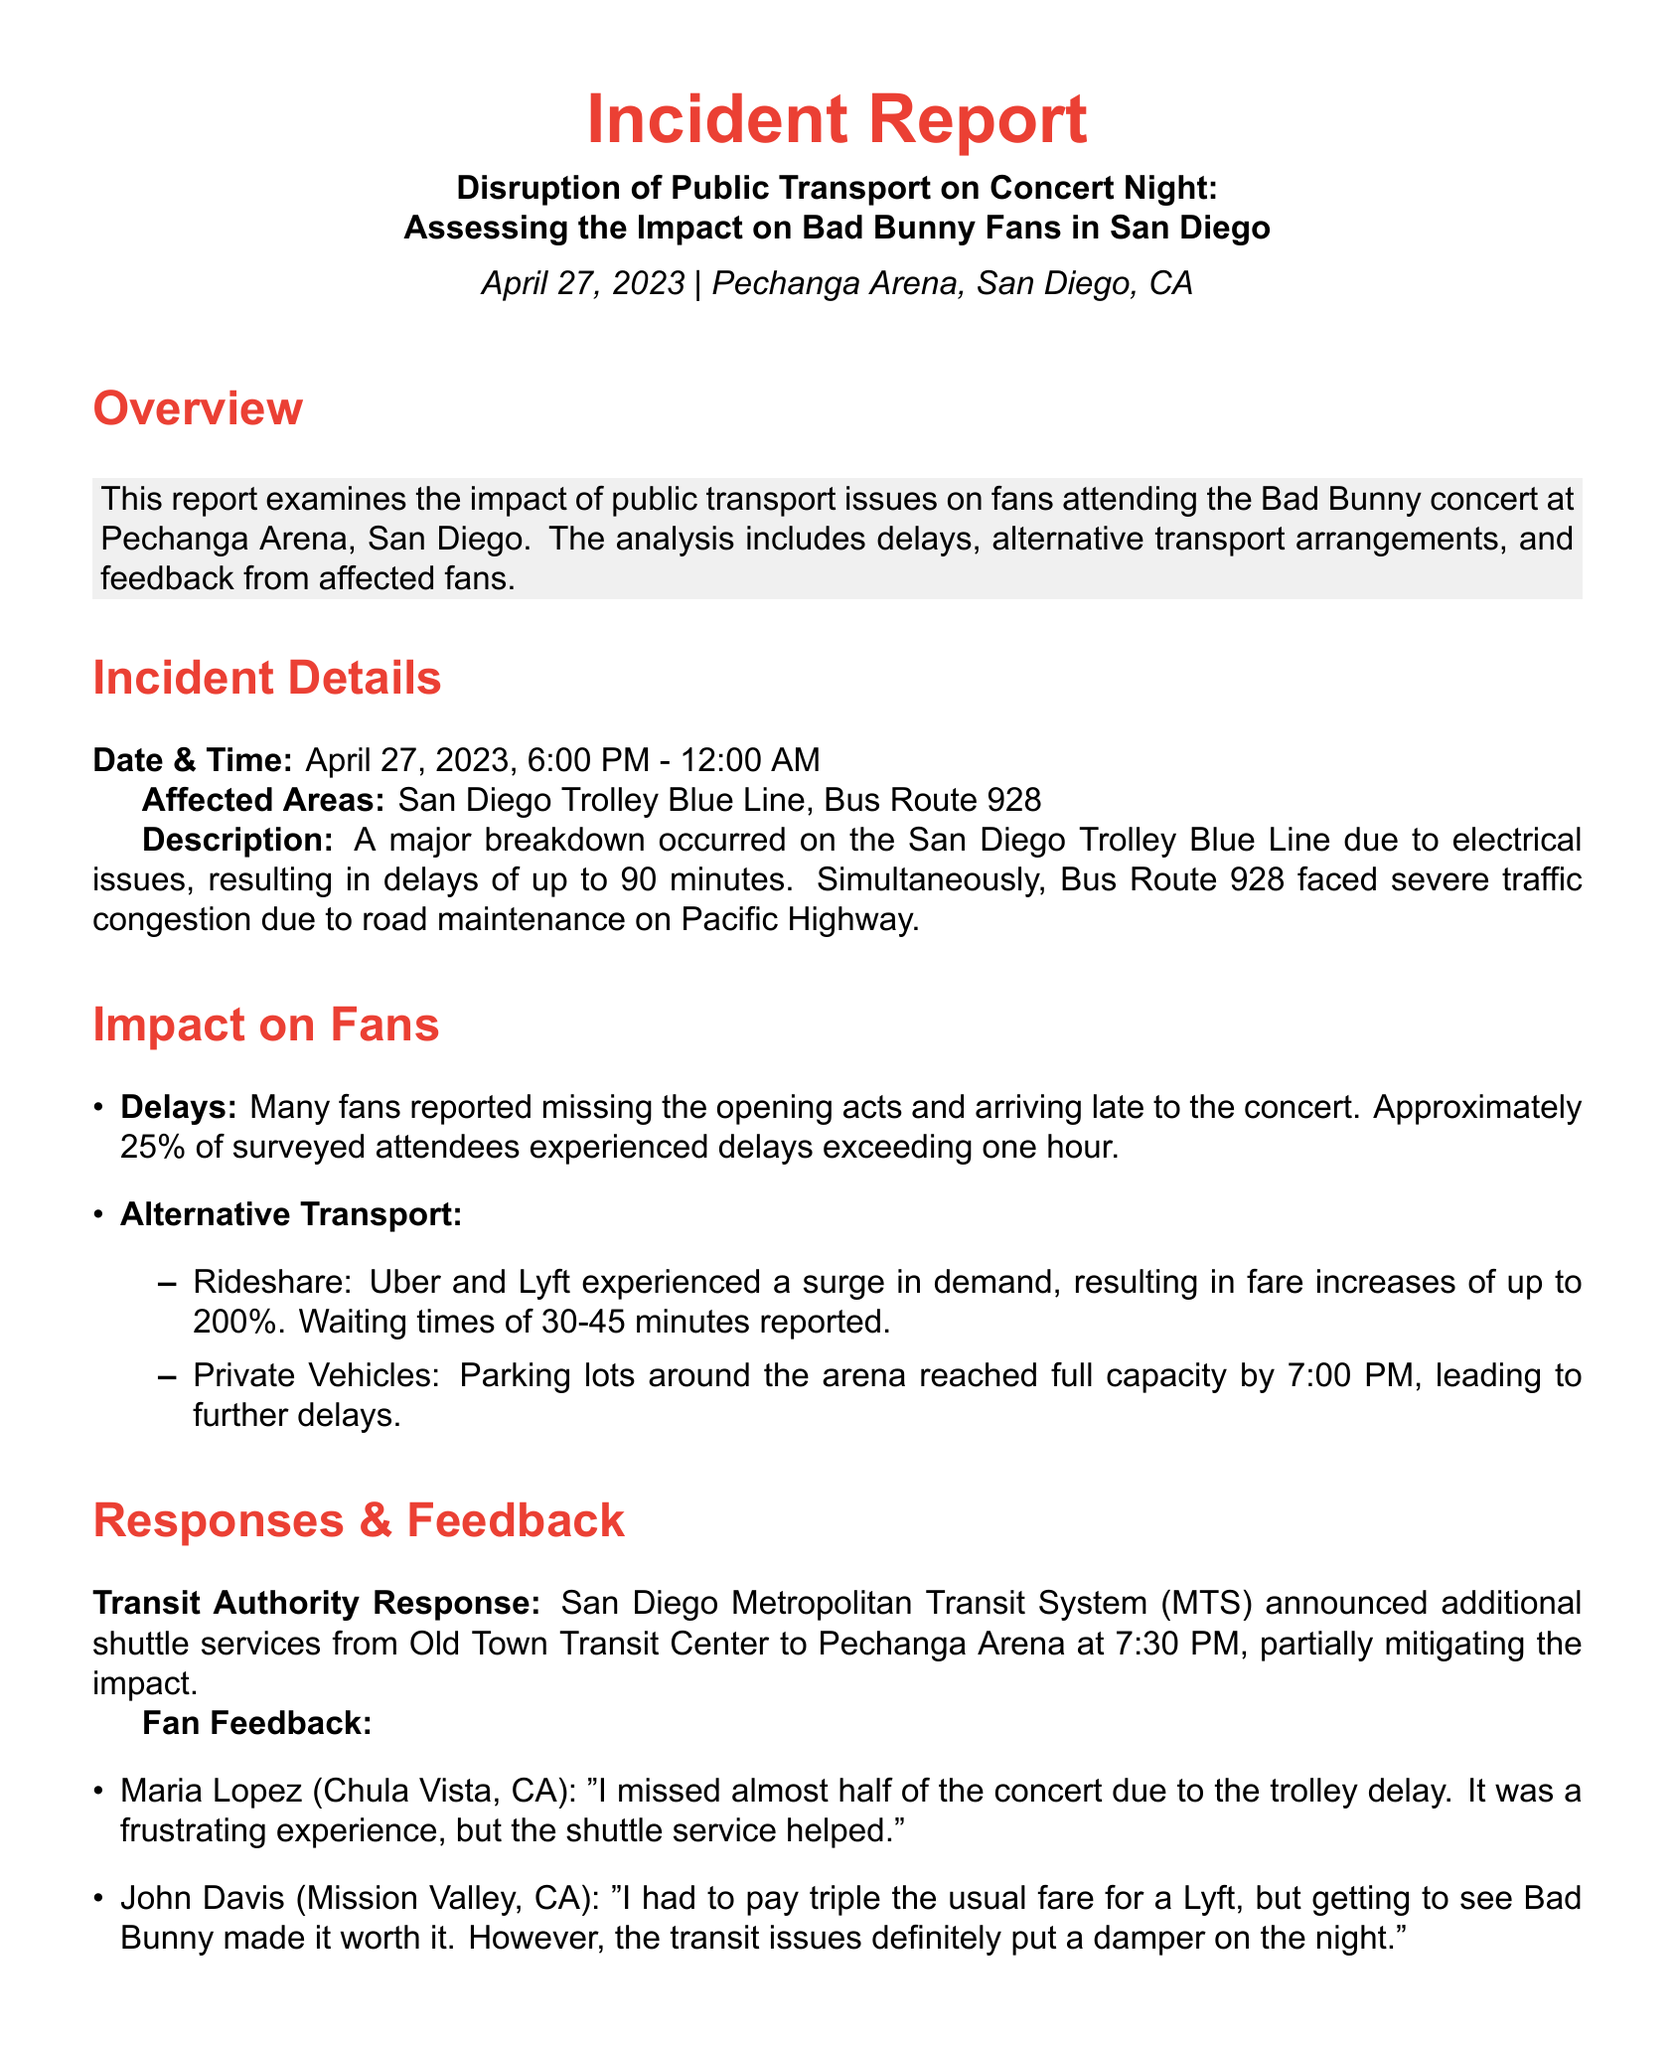What is the date of the concert? The concert took place on April 27, 2023.
Answer: April 27, 2023 What were the affected public transport routes? The affected routes included the San Diego Trolley Blue Line and Bus Route 928.
Answer: San Diego Trolley Blue Line, Bus Route 928 How long were fans delayed on average? Approximately 25% of surveyed attendees experienced delays exceeding one hour.
Answer: One hour What percentage of fans missed the opening acts? The report states that approximately 25% of surveyed attendees experienced delays.
Answer: 25% What was one alternative transport option used by fans? Fans used rideshare services such as Uber and Lyft.
Answer: Rideshare What was the increase in fare for rideshare services? Fare increases for rideshare services were reported to be up to 200%.
Answer: 200% At what time did parking lots around the arena reach full capacity? Parking lots were at full capacity by 7:00 PM.
Answer: 7:00 PM What response did the Transit Authority have to the incident? The San Diego Metropolitan Transit System announced additional shuttle services at 7:30 PM.
Answer: Additional shuttle services What feedback did Maria Lopez provide regarding her concert experience? Maria Lopez mentioned that she missed almost half of the concert due to the trolley delay.
Answer: Missed almost half of the concert What recommendation is suggested regarding shuttle services? The report recommends increasing frequency and capacity of shuttle services during major events.
Answer: Increase frequency and capacity 